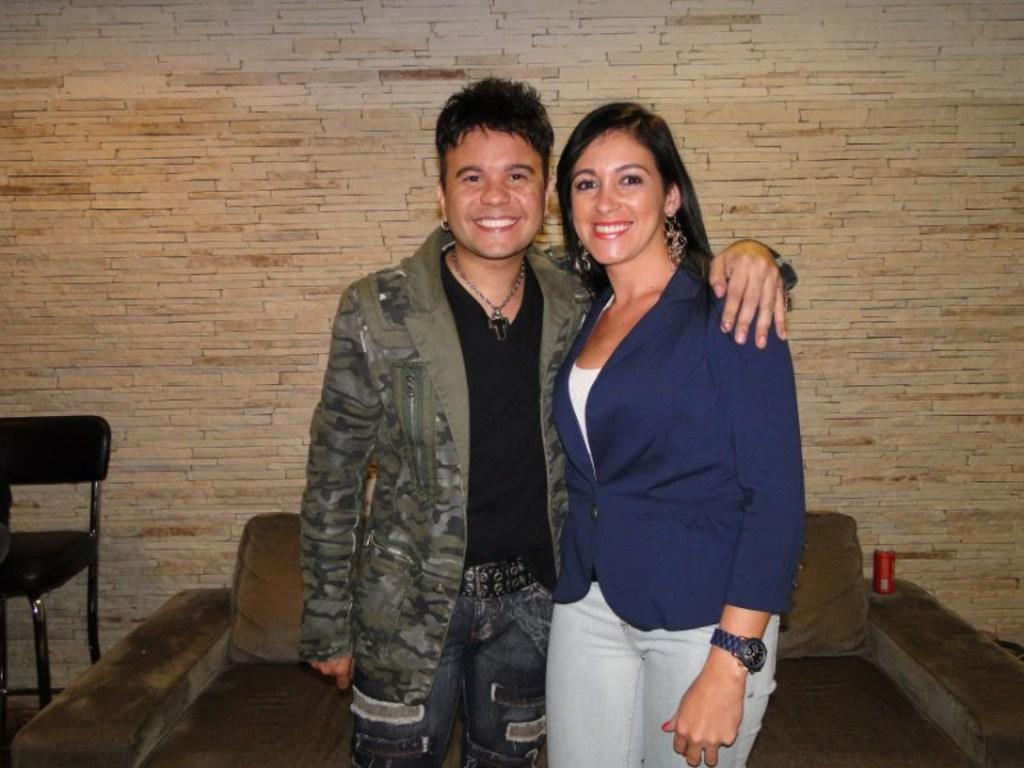How many people are in the image? There are two persons in the image. What are the two persons doing? The two persons are hugging each other. What can be seen in the background of the image? There is a wall and a couch in the background of the image. What type of grass is being used to hold the feast in the image? There is no feast or grass present in the image; it features two persons hugging each other with a wall and a couch in the background. 